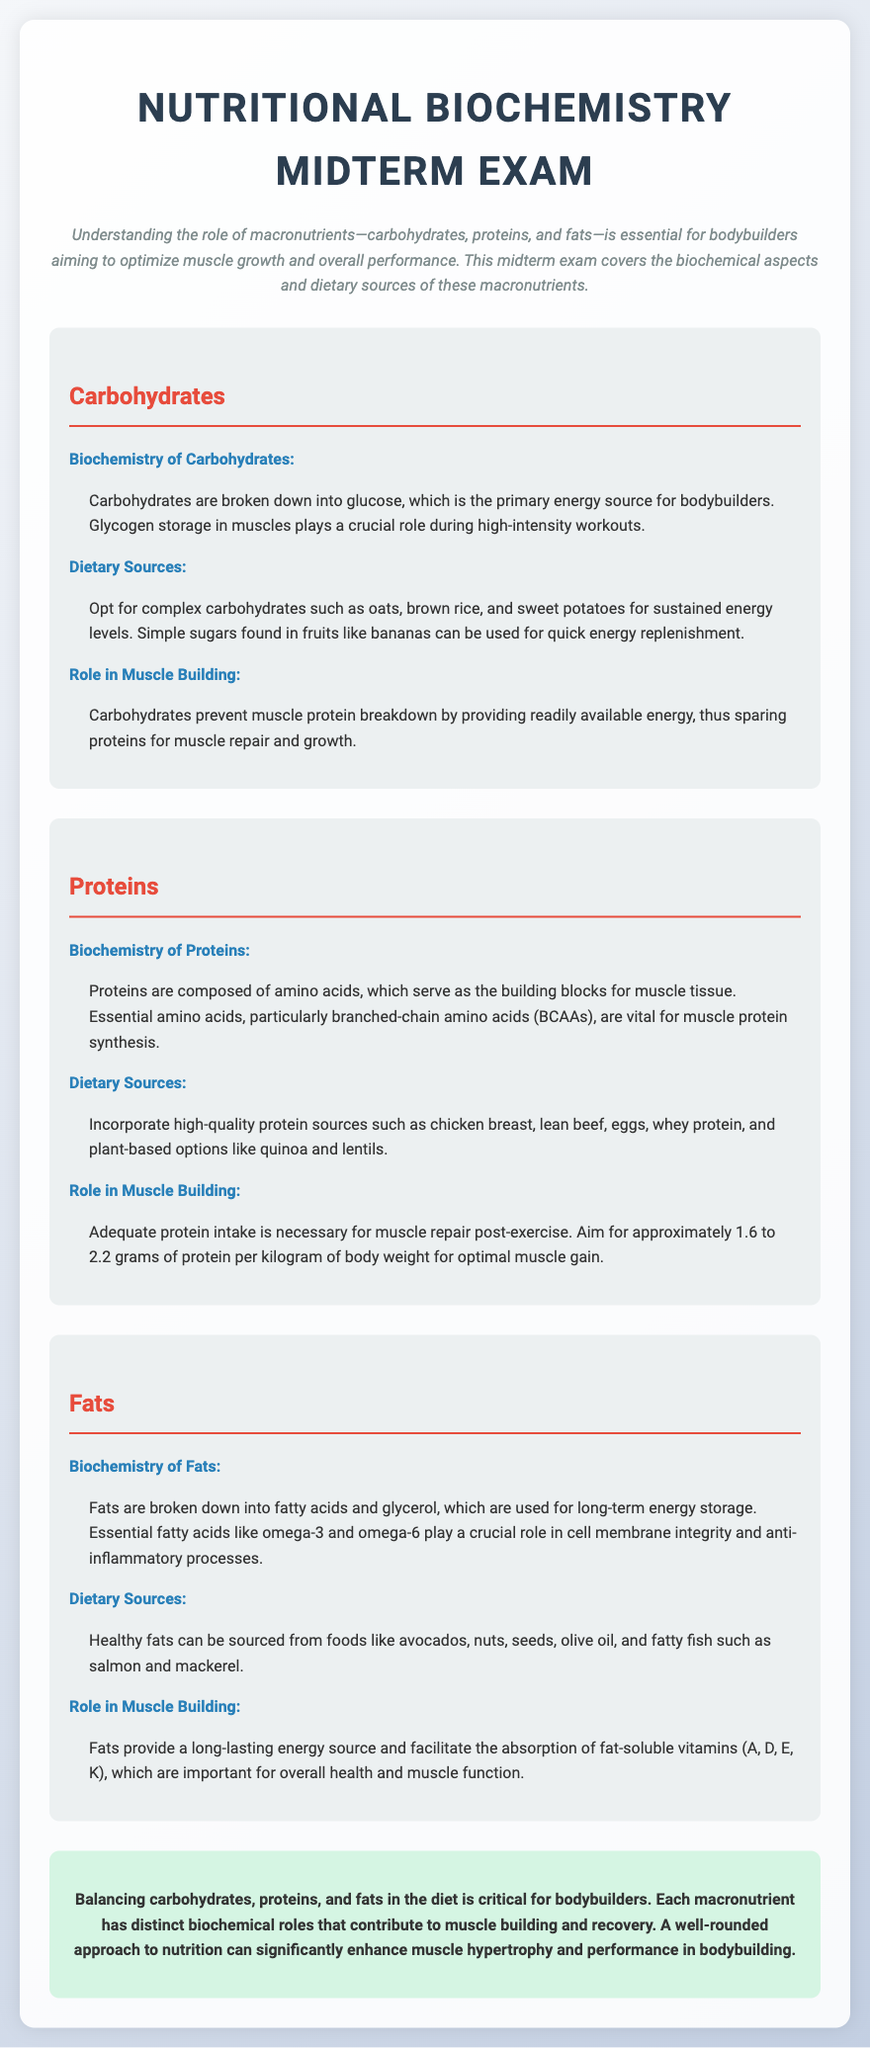What is the primary energy source for bodybuilders? The document states that carbohydrates are broken down into glucose, which is the primary energy source for bodybuilders.
Answer: Glucose What role do carbohydrates play in muscle building? The document explains that carbohydrates prevent muscle protein breakdown by providing readily available energy.
Answer: Prevent muscle protein breakdown What is the recommended protein intake for optimal muscle gain per kilogram of body weight? The document mentions that the aim should be approximately 1.6 to 2.2 grams of protein per kilogram of body weight.
Answer: 1.6 to 2.2 grams Name two essential fatty acids mentioned in the document. The document mentions omega-3 and omega-6 as essential fatty acids.
Answer: Omega-3 and omega-6 What are two high-quality protein sources listed in the document? The document lists chicken breast and lean beef as high-quality protein sources.
Answer: Chicken breast, lean beef Where is glycogen stored in the body? According to the document, glycogen is stored in muscles.
Answer: Muscles How do fats facilitate nutrient absorption? The document states that fats facilitate the absorption of fat-soluble vitamins A, D, E, and K.
Answer: Fat-soluble vitamins A, D, E, K What type of carbohydrates should bodybuilders opt for to maintain sustained energy levels? The document suggests opting for complex carbohydrates like oats, brown rice, and sweet potatoes for sustained energy.
Answer: Complex carbohydrates What is the conclusion regarding the balance of macronutrients for bodybuilders? The document concludes that balancing carbohydrates, proteins, and fats in the diet is critical for bodybuilders.
Answer: Balancing macronutrients is critical 